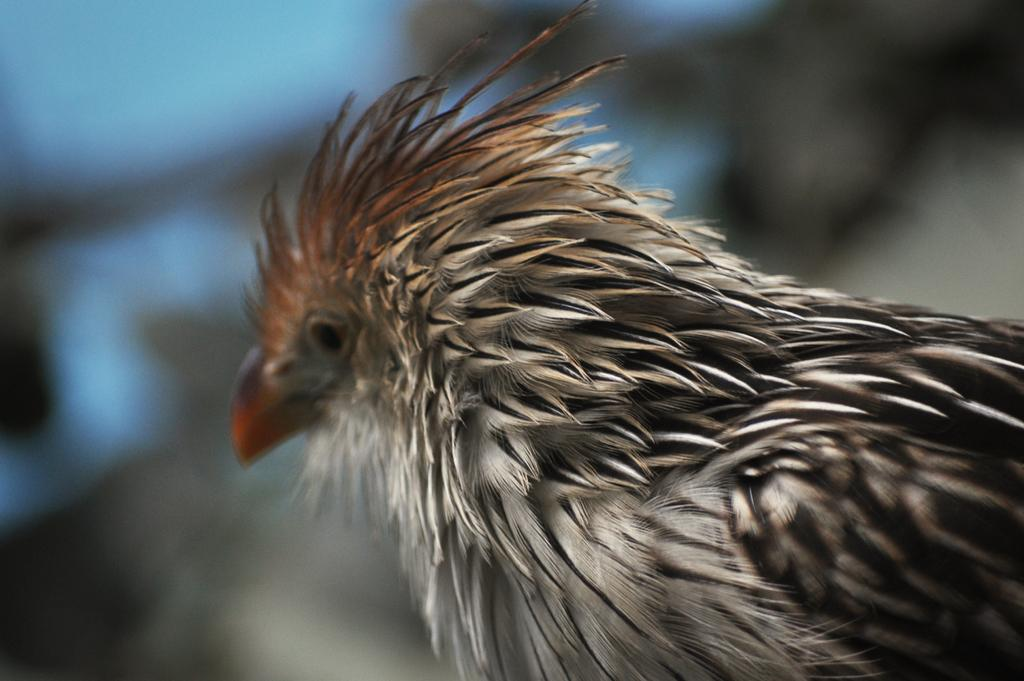What type of animal is present in the image? There is a bird in the image. Can you see any monkeys playing during the recess in the image? There is no reference to a recess or monkeys in the image; it features a bird. 